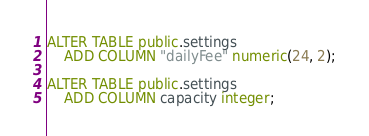<code> <loc_0><loc_0><loc_500><loc_500><_SQL_>ALTER TABLE public.settings
    ADD COLUMN "dailyFee" numeric(24, 2);

ALTER TABLE public.settings
    ADD COLUMN capacity integer;</code> 